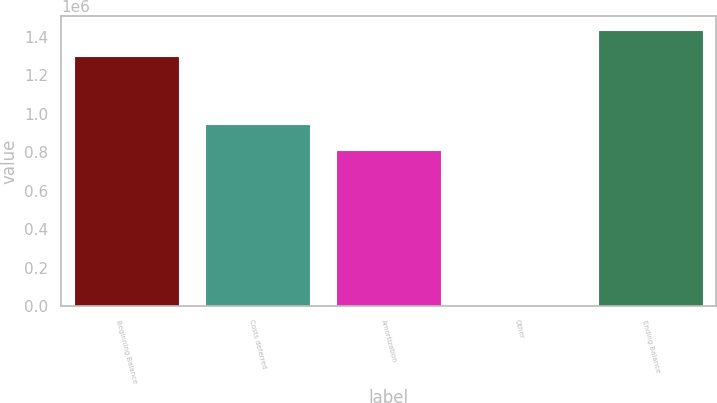Convert chart to OTSL. <chart><loc_0><loc_0><loc_500><loc_500><bar_chart><fcel>Beginning Balance<fcel>Costs deferred<fcel>Amortization<fcel>Other<fcel>Ending Balance<nl><fcel>1.2988e+06<fcel>948852<fcel>810814<fcel>4444<fcel>1.43684e+06<nl></chart> 